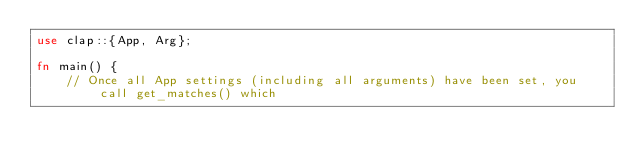Convert code to text. <code><loc_0><loc_0><loc_500><loc_500><_Rust_>use clap::{App, Arg};

fn main() {
    // Once all App settings (including all arguments) have been set, you call get_matches() which</code> 